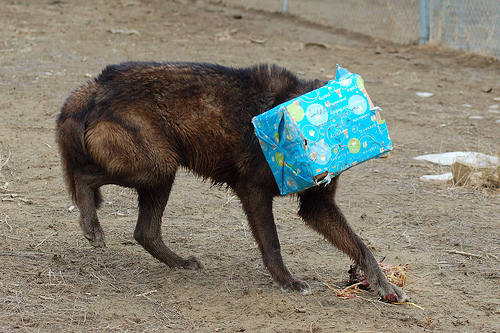<image>
Can you confirm if the box is on the dog? Yes. Looking at the image, I can see the box is positioned on top of the dog, with the dog providing support. Is there a box in front of the dog? Yes. The box is positioned in front of the dog, appearing closer to the camera viewpoint. 